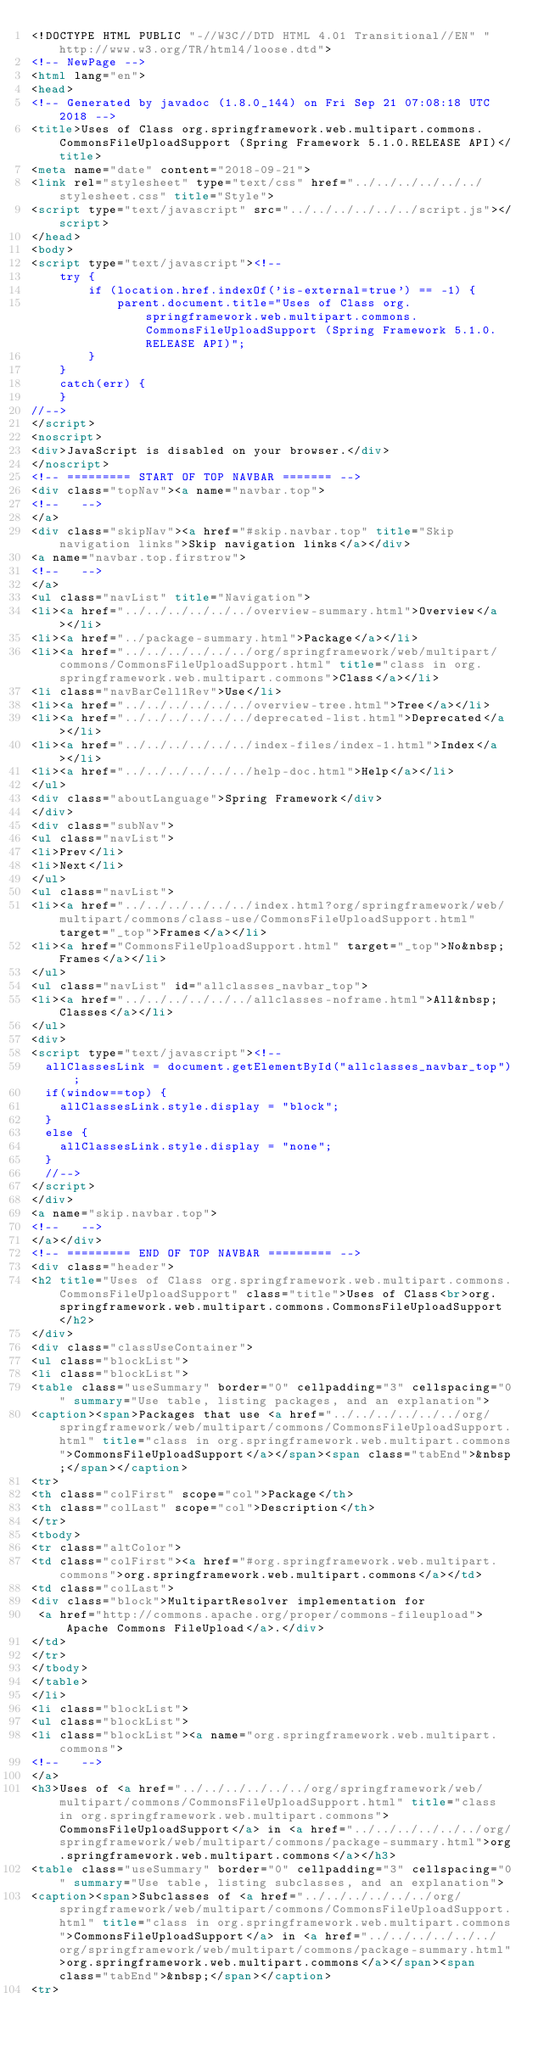<code> <loc_0><loc_0><loc_500><loc_500><_HTML_><!DOCTYPE HTML PUBLIC "-//W3C//DTD HTML 4.01 Transitional//EN" "http://www.w3.org/TR/html4/loose.dtd">
<!-- NewPage -->
<html lang="en">
<head>
<!-- Generated by javadoc (1.8.0_144) on Fri Sep 21 07:08:18 UTC 2018 -->
<title>Uses of Class org.springframework.web.multipart.commons.CommonsFileUploadSupport (Spring Framework 5.1.0.RELEASE API)</title>
<meta name="date" content="2018-09-21">
<link rel="stylesheet" type="text/css" href="../../../../../../stylesheet.css" title="Style">
<script type="text/javascript" src="../../../../../../script.js"></script>
</head>
<body>
<script type="text/javascript"><!--
    try {
        if (location.href.indexOf('is-external=true') == -1) {
            parent.document.title="Uses of Class org.springframework.web.multipart.commons.CommonsFileUploadSupport (Spring Framework 5.1.0.RELEASE API)";
        }
    }
    catch(err) {
    }
//-->
</script>
<noscript>
<div>JavaScript is disabled on your browser.</div>
</noscript>
<!-- ========= START OF TOP NAVBAR ======= -->
<div class="topNav"><a name="navbar.top">
<!--   -->
</a>
<div class="skipNav"><a href="#skip.navbar.top" title="Skip navigation links">Skip navigation links</a></div>
<a name="navbar.top.firstrow">
<!--   -->
</a>
<ul class="navList" title="Navigation">
<li><a href="../../../../../../overview-summary.html">Overview</a></li>
<li><a href="../package-summary.html">Package</a></li>
<li><a href="../../../../../../org/springframework/web/multipart/commons/CommonsFileUploadSupport.html" title="class in org.springframework.web.multipart.commons">Class</a></li>
<li class="navBarCell1Rev">Use</li>
<li><a href="../../../../../../overview-tree.html">Tree</a></li>
<li><a href="../../../../../../deprecated-list.html">Deprecated</a></li>
<li><a href="../../../../../../index-files/index-1.html">Index</a></li>
<li><a href="../../../../../../help-doc.html">Help</a></li>
</ul>
<div class="aboutLanguage">Spring Framework</div>
</div>
<div class="subNav">
<ul class="navList">
<li>Prev</li>
<li>Next</li>
</ul>
<ul class="navList">
<li><a href="../../../../../../index.html?org/springframework/web/multipart/commons/class-use/CommonsFileUploadSupport.html" target="_top">Frames</a></li>
<li><a href="CommonsFileUploadSupport.html" target="_top">No&nbsp;Frames</a></li>
</ul>
<ul class="navList" id="allclasses_navbar_top">
<li><a href="../../../../../../allclasses-noframe.html">All&nbsp;Classes</a></li>
</ul>
<div>
<script type="text/javascript"><!--
  allClassesLink = document.getElementById("allclasses_navbar_top");
  if(window==top) {
    allClassesLink.style.display = "block";
  }
  else {
    allClassesLink.style.display = "none";
  }
  //-->
</script>
</div>
<a name="skip.navbar.top">
<!--   -->
</a></div>
<!-- ========= END OF TOP NAVBAR ========= -->
<div class="header">
<h2 title="Uses of Class org.springframework.web.multipart.commons.CommonsFileUploadSupport" class="title">Uses of Class<br>org.springframework.web.multipart.commons.CommonsFileUploadSupport</h2>
</div>
<div class="classUseContainer">
<ul class="blockList">
<li class="blockList">
<table class="useSummary" border="0" cellpadding="3" cellspacing="0" summary="Use table, listing packages, and an explanation">
<caption><span>Packages that use <a href="../../../../../../org/springframework/web/multipart/commons/CommonsFileUploadSupport.html" title="class in org.springframework.web.multipart.commons">CommonsFileUploadSupport</a></span><span class="tabEnd">&nbsp;</span></caption>
<tr>
<th class="colFirst" scope="col">Package</th>
<th class="colLast" scope="col">Description</th>
</tr>
<tbody>
<tr class="altColor">
<td class="colFirst"><a href="#org.springframework.web.multipart.commons">org.springframework.web.multipart.commons</a></td>
<td class="colLast">
<div class="block">MultipartResolver implementation for
 <a href="http://commons.apache.org/proper/commons-fileupload">Apache Commons FileUpload</a>.</div>
</td>
</tr>
</tbody>
</table>
</li>
<li class="blockList">
<ul class="blockList">
<li class="blockList"><a name="org.springframework.web.multipart.commons">
<!--   -->
</a>
<h3>Uses of <a href="../../../../../../org/springframework/web/multipart/commons/CommonsFileUploadSupport.html" title="class in org.springframework.web.multipart.commons">CommonsFileUploadSupport</a> in <a href="../../../../../../org/springframework/web/multipart/commons/package-summary.html">org.springframework.web.multipart.commons</a></h3>
<table class="useSummary" border="0" cellpadding="3" cellspacing="0" summary="Use table, listing subclasses, and an explanation">
<caption><span>Subclasses of <a href="../../../../../../org/springframework/web/multipart/commons/CommonsFileUploadSupport.html" title="class in org.springframework.web.multipart.commons">CommonsFileUploadSupport</a> in <a href="../../../../../../org/springframework/web/multipart/commons/package-summary.html">org.springframework.web.multipart.commons</a></span><span class="tabEnd">&nbsp;</span></caption>
<tr></code> 